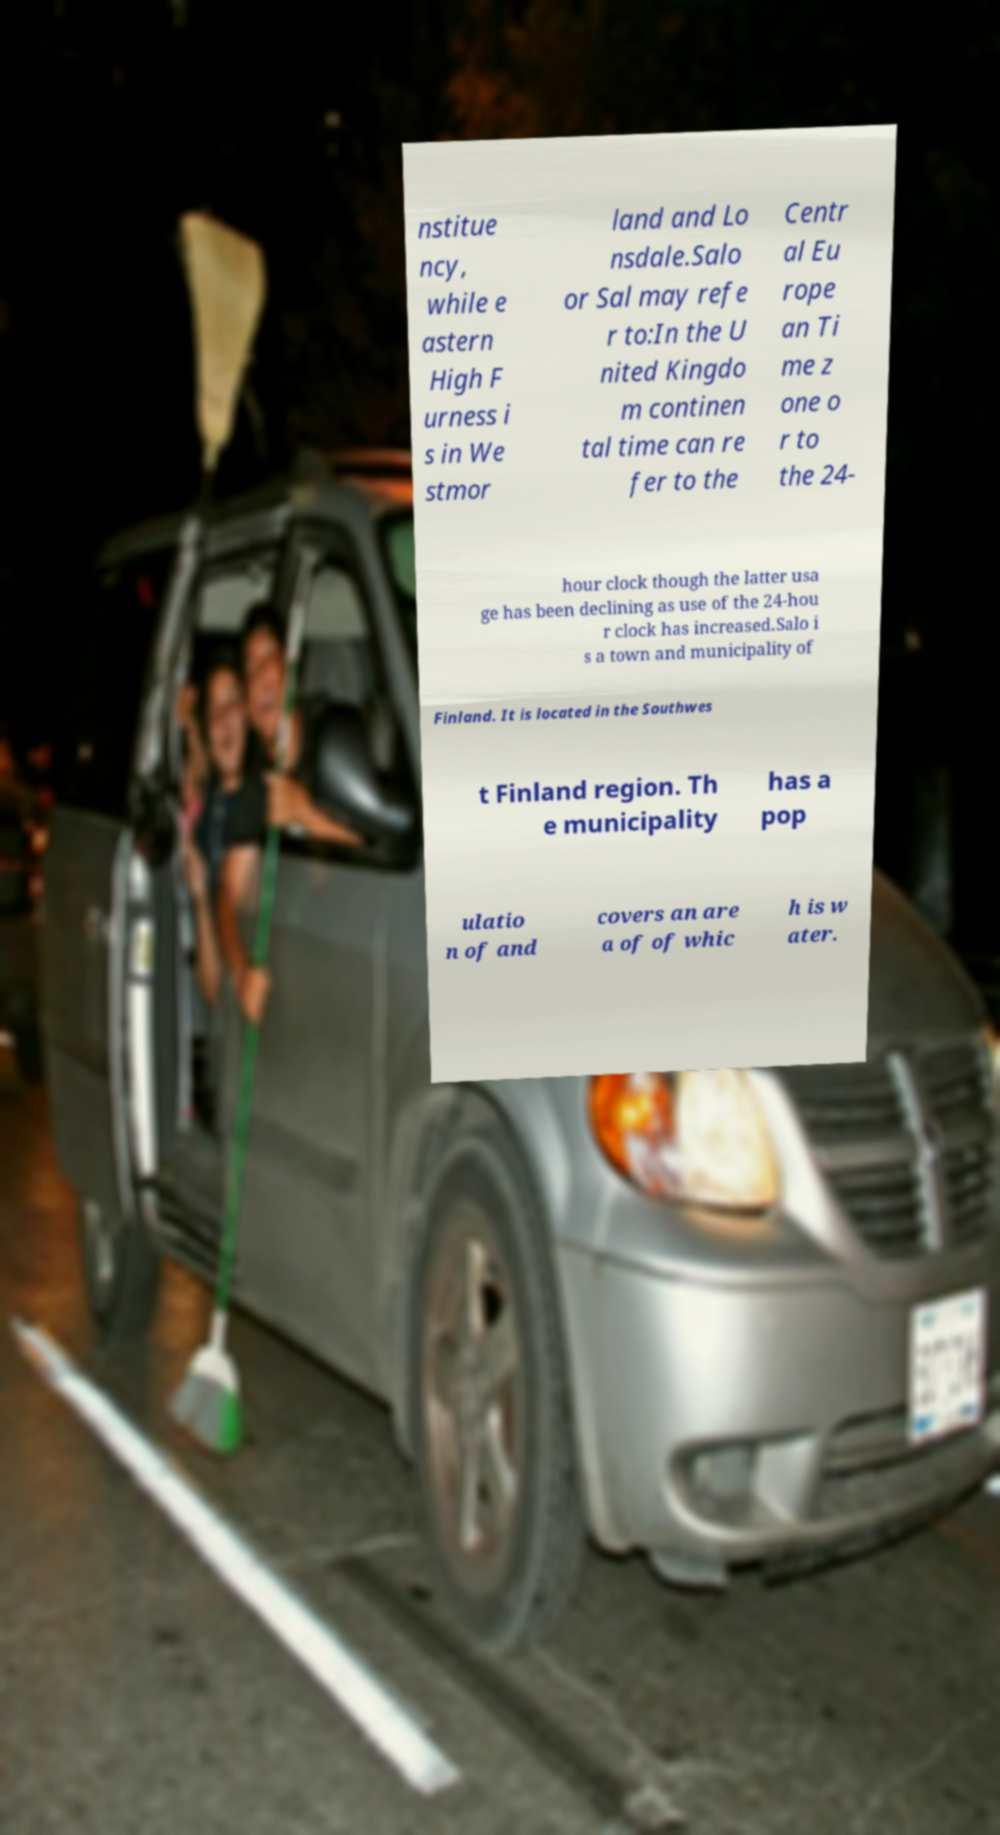Please identify and transcribe the text found in this image. nstitue ncy, while e astern High F urness i s in We stmor land and Lo nsdale.Salo or Sal may refe r to:In the U nited Kingdo m continen tal time can re fer to the Centr al Eu rope an Ti me z one o r to the 24- hour clock though the latter usa ge has been declining as use of the 24-hou r clock has increased.Salo i s a town and municipality of Finland. It is located in the Southwes t Finland region. Th e municipality has a pop ulatio n of and covers an are a of of whic h is w ater. 